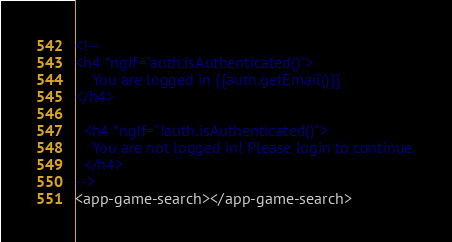<code> <loc_0><loc_0><loc_500><loc_500><_HTML_>
<!--  
<h4 *ngIf="auth.isAuthenticated()">
    You are logged in {{auth.getEmail()}}
</h4>

  <h4 *ngIf="!auth.isAuthenticated()">
    You are not logged in! Please login to continue.
  </h4>
-->
<app-game-search></app-game-search></code> 